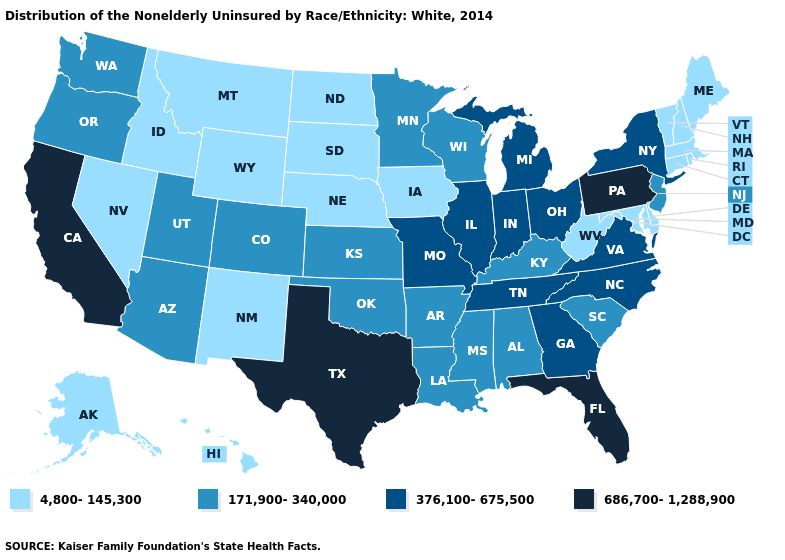Name the states that have a value in the range 171,900-340,000?
Short answer required. Alabama, Arizona, Arkansas, Colorado, Kansas, Kentucky, Louisiana, Minnesota, Mississippi, New Jersey, Oklahoma, Oregon, South Carolina, Utah, Washington, Wisconsin. Name the states that have a value in the range 171,900-340,000?
Give a very brief answer. Alabama, Arizona, Arkansas, Colorado, Kansas, Kentucky, Louisiana, Minnesota, Mississippi, New Jersey, Oklahoma, Oregon, South Carolina, Utah, Washington, Wisconsin. Among the states that border Nebraska , which have the highest value?
Keep it brief. Missouri. What is the highest value in states that border Texas?
Be succinct. 171,900-340,000. What is the value of Washington?
Give a very brief answer. 171,900-340,000. Does New Mexico have the lowest value in the USA?
Short answer required. Yes. What is the value of California?
Short answer required. 686,700-1,288,900. Which states hav the highest value in the MidWest?
Answer briefly. Illinois, Indiana, Michigan, Missouri, Ohio. Name the states that have a value in the range 376,100-675,500?
Concise answer only. Georgia, Illinois, Indiana, Michigan, Missouri, New York, North Carolina, Ohio, Tennessee, Virginia. Which states have the lowest value in the USA?
Answer briefly. Alaska, Connecticut, Delaware, Hawaii, Idaho, Iowa, Maine, Maryland, Massachusetts, Montana, Nebraska, Nevada, New Hampshire, New Mexico, North Dakota, Rhode Island, South Dakota, Vermont, West Virginia, Wyoming. What is the value of New Mexico?
Give a very brief answer. 4,800-145,300. Name the states that have a value in the range 171,900-340,000?
Give a very brief answer. Alabama, Arizona, Arkansas, Colorado, Kansas, Kentucky, Louisiana, Minnesota, Mississippi, New Jersey, Oklahoma, Oregon, South Carolina, Utah, Washington, Wisconsin. What is the value of Alaska?
Keep it brief. 4,800-145,300. What is the value of California?
Write a very short answer. 686,700-1,288,900. Name the states that have a value in the range 686,700-1,288,900?
Write a very short answer. California, Florida, Pennsylvania, Texas. 